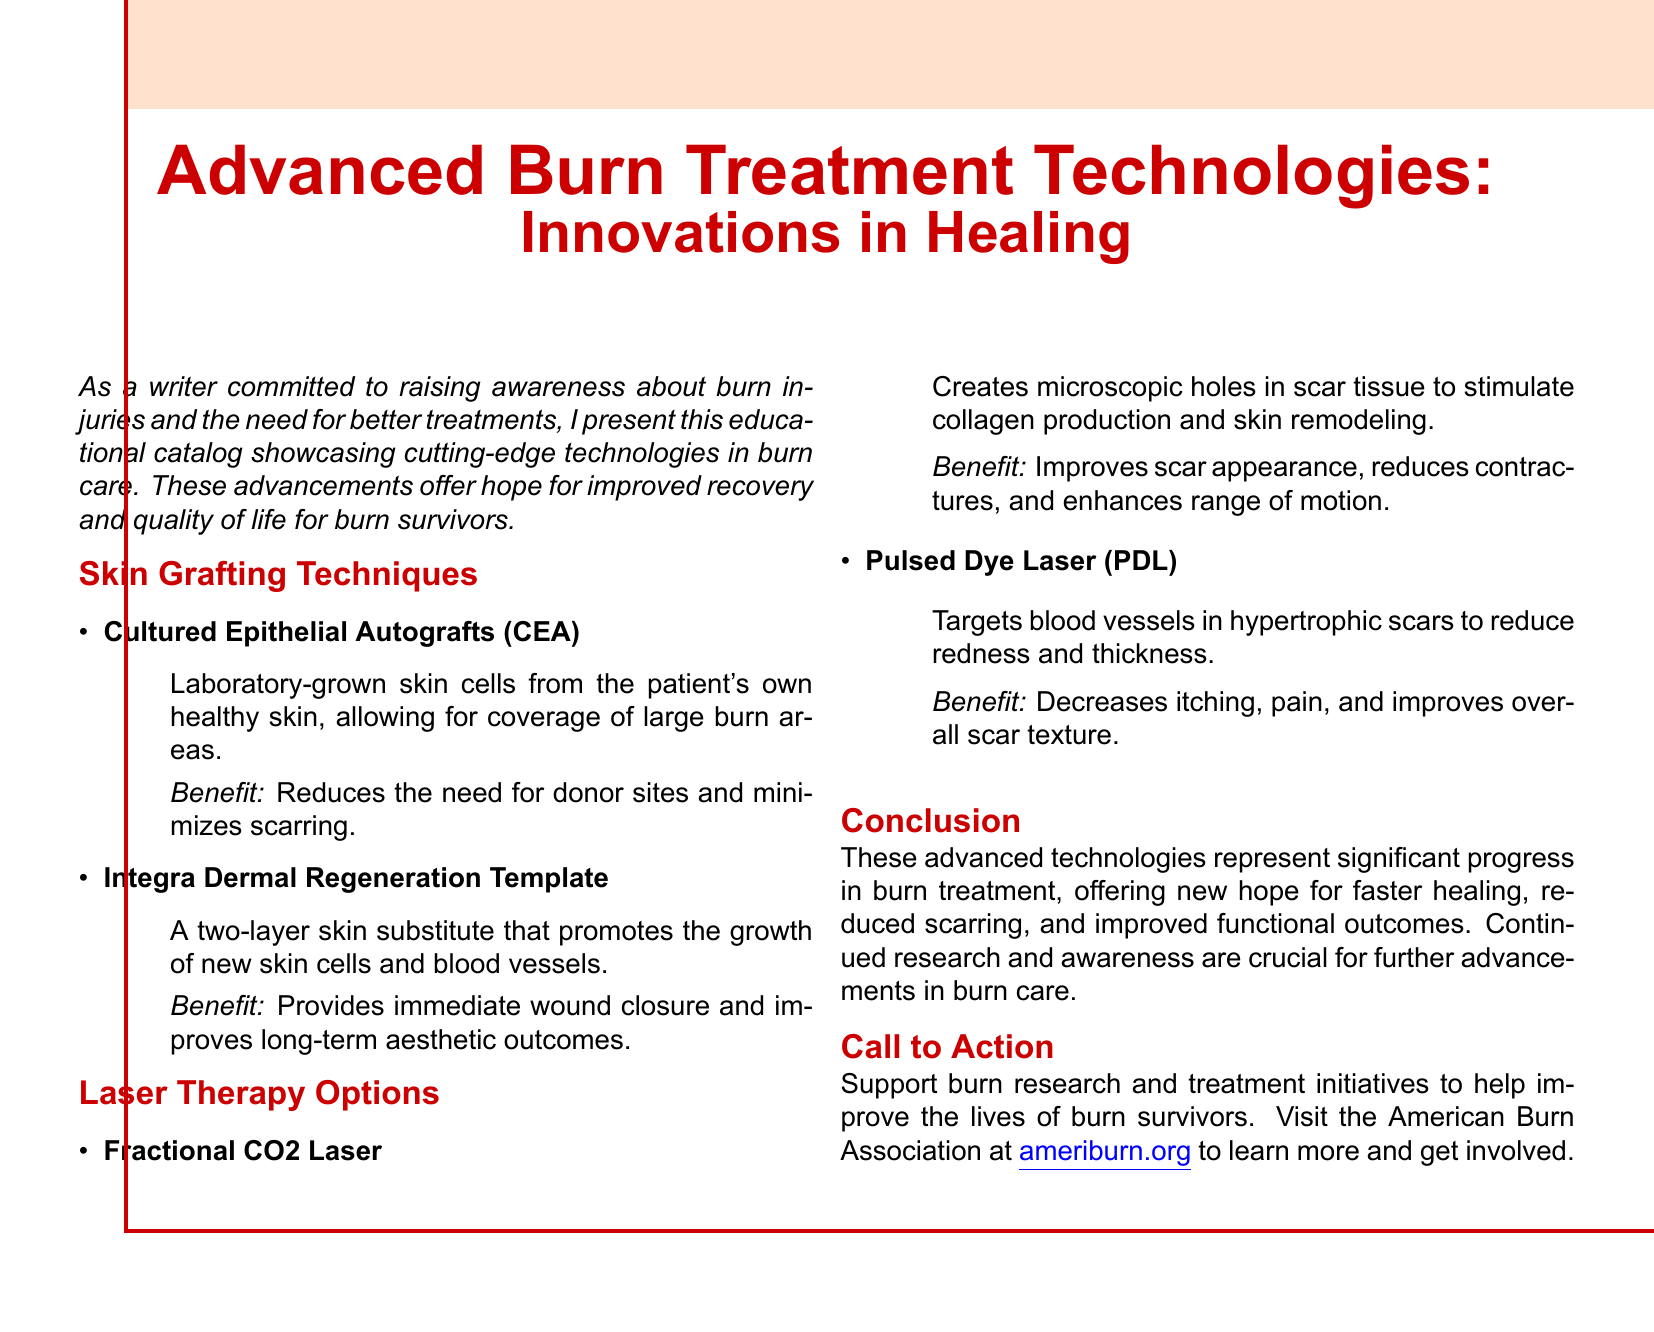What are Cultured Epithelial Autografts? Cultured Epithelial Autografts (CEA) are laboratory-grown skin cells from the patient's own healthy skin.
Answer: Laboratory-grown skin cells What does the Integra Dermal Regeneration Template promote? The Integra Dermal Regeneration Template promotes the growth of new skin cells and blood vessels.
Answer: Growth of new skin cells and blood vessels What is the benefit of using Fractional CO2 Laser? The benefit of using Fractional CO2 Laser is that it improves scar appearance, reduces contractures, and enhances range of motion.
Answer: Improves scar appearance What does Pulsed Dye Laser target? Pulsed Dye Laser targets blood vessels in hypertrophic scars.
Answer: Blood vessels in hypertrophic scars What is the call to action in the document? The call to action encourages support for burn research and treatment initiatives.
Answer: Support burn research and treatment initiatives 